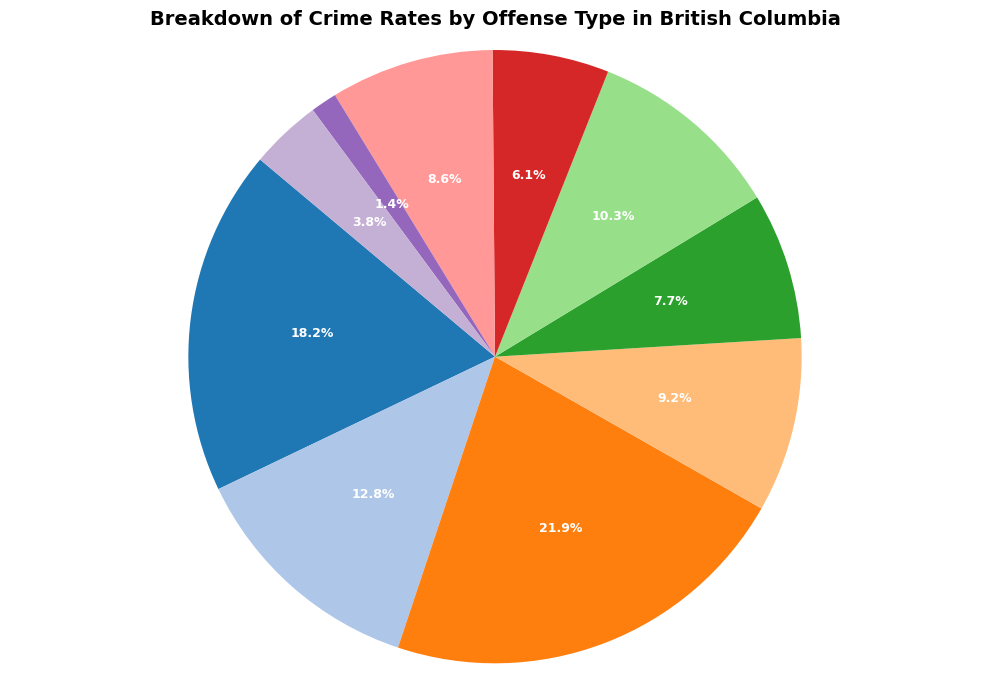What is the most common type of offense? To identify the most common type of offense, look for the largest slice of the pie chart and check its label. The type associated with the largest percentage value is the most common offense.
Answer: Theft Which offense type has a higher percentage, Vandalism or Sexual Offenses? Compare the slices labeled "Vandalism" and "Sexual Offenses," and note their percentages. Vandalism has 7.8%, while Sexual Offenses has 3.8%.
Answer: Vandalism What is the combined percentage of Assault and Burglary? Locate the slices labeled "Assault" and "Burglary" and note their percentages. Sum the two percentages: Assault (18.4%) + Burglary (12.9%) = 31.3%.
Answer: 31.3% Are Drug Offenses more or less common than Vehicle Theft? Compare the slices labeled "Drug Offenses" and "Vehicle Theft." Drug Offenses have 9.3%, whereas Vehicle Theft has 8.7%.
Answer: More How much larger is the percentage of Theft compared to Fraud? Find the slices labeled "Theft" and "Fraud" and note their percentages. Subtract Fraud's percentage from Theft's: 22.1% - 10.4% = 11.7%.
Answer: 11.7% Which offense type accounts for the smallest percentage of crimes? Identify the smallest slice of the pie chart and note its label and percentage. Homicide is the smallest with 1.4%.
Answer: Homicide What proportion of crimes are accounted for by Fraud and Robbery combined? Locate the slices labeled "Fraud" and "Robbery" and sum their percentages: Fraud (10.4%) + Robbery (6.2%) = 16.6%.
Answer: 16.6% Are Sexual Offenses or Homicide less frequent? Compare the slices labeled "Sexual Offenses" and "Homicide." Sexual Offenses have 3.8%, while Homicide has 1.4%.
Answer: Homicide What is the difference in percentage between the most common offense type and the least common offense type? Identify the most common offense (Theft with 22.1%) and the least common offense (Homicide with 1.4%). Subtract Homicide's percentage from Theft's: 22.1% - 1.4% = 20.7%.
Answer: 20.7% What percentage of crimes is attributed to non-violent offenses (Theft, Burglary, Fraud, and Vandalism)? Sum the percentages of Theft, Burglary, Fraud, and Vandalism: 22.1% (Theft) + 12.9% (Burglary) + 10.4% (Fraud) + 7.8% (Vandalism) = 53.2%.
Answer: 53.2% 